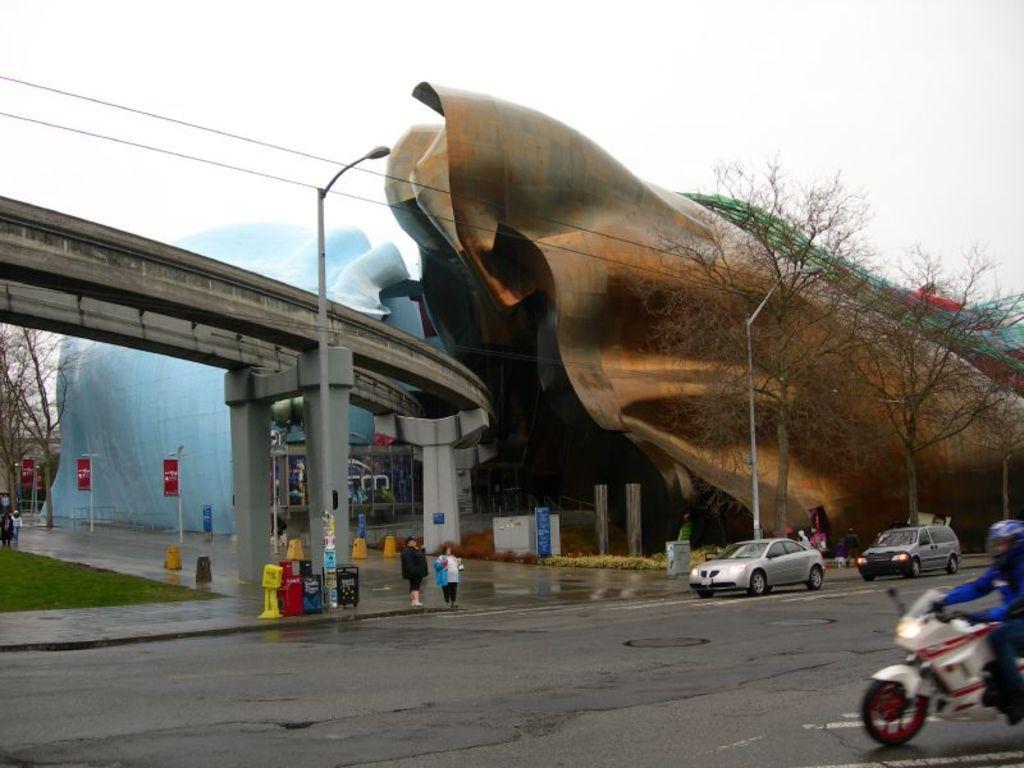Please provide a concise description of this image. In this image there are some vehicles and some persons are walking, and also there are some poles, boards, light. On the left side there is a bridge and in the background there are some buildings and trees, at the bottom there is a road and at the top of the image there is sky. 